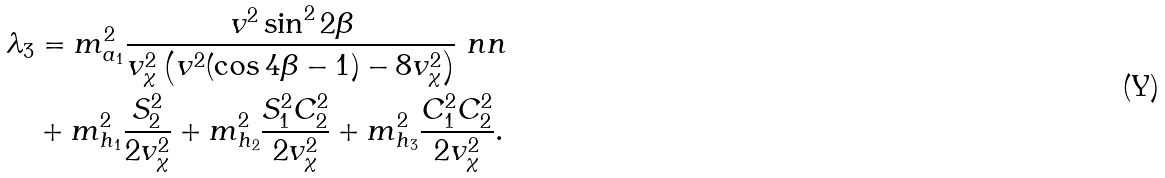Convert formula to latex. <formula><loc_0><loc_0><loc_500><loc_500>\lambda _ { 3 } & = m ^ { 2 } _ { a _ { 1 } } \frac { v ^ { 2 } \sin ^ { 2 } 2 \beta } { v _ { \chi } ^ { 2 } \left ( v ^ { 2 } ( \cos 4 \beta - 1 ) - 8 v _ { \chi } ^ { 2 } \right ) } \ n n \\ & + m ^ { 2 } _ { h _ { 1 } } \frac { S ^ { 2 } _ { 2 } } { 2 v _ { \chi } ^ { 2 } } + m ^ { 2 } _ { h _ { 2 } } \frac { S ^ { 2 } _ { 1 } C ^ { 2 } _ { 2 } } { 2 v _ { \chi } ^ { 2 } } + m ^ { 2 } _ { h _ { 3 } } \frac { C ^ { 2 } _ { 1 } C ^ { 2 } _ { 2 } } { 2 v _ { \chi } ^ { 2 } } .</formula> 